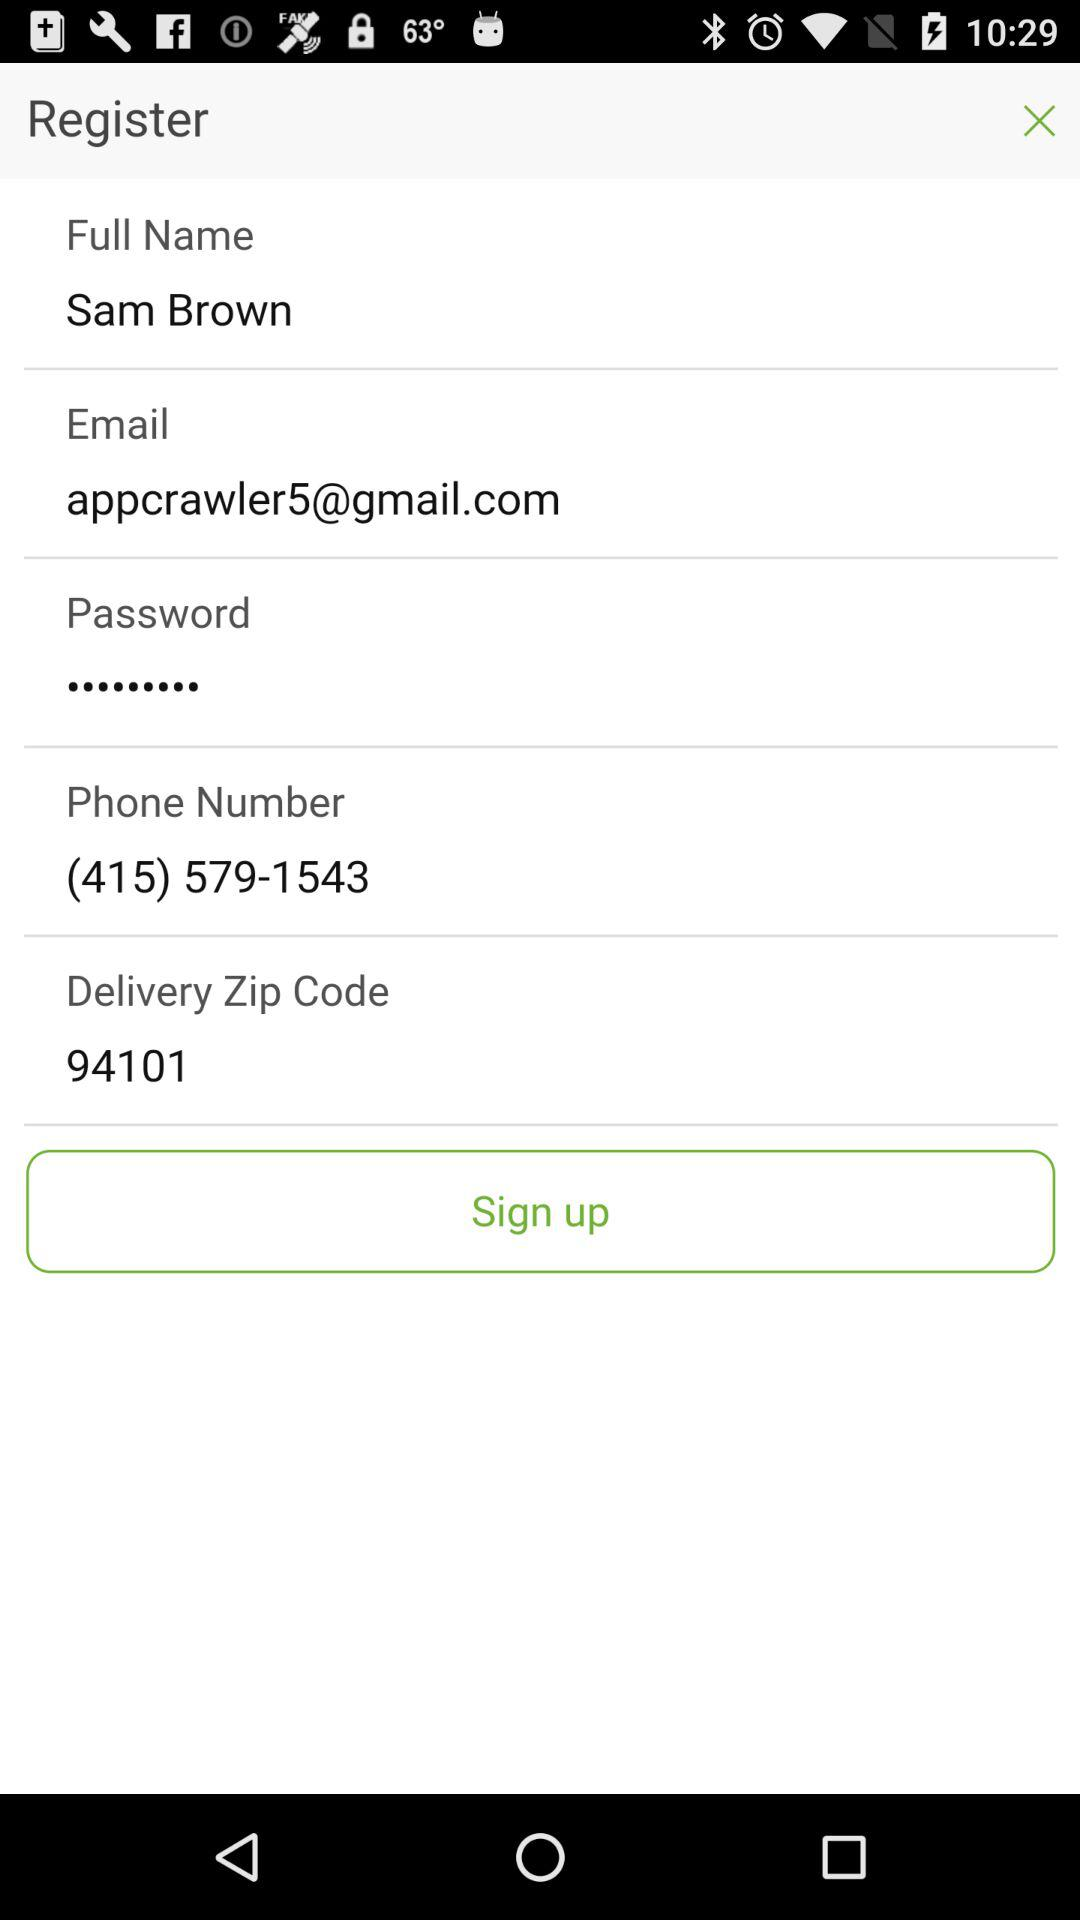How many text inputs require the user to enter a phone number?
Answer the question using a single word or phrase. 1 